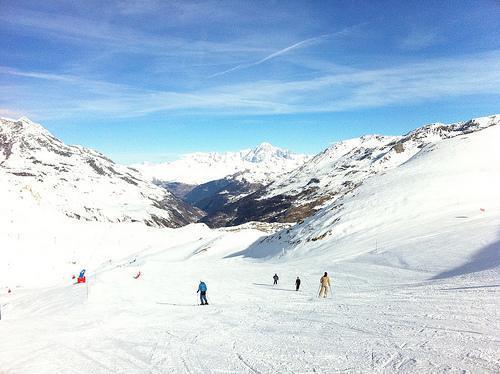How many people skiing?
Give a very brief answer. 4. 